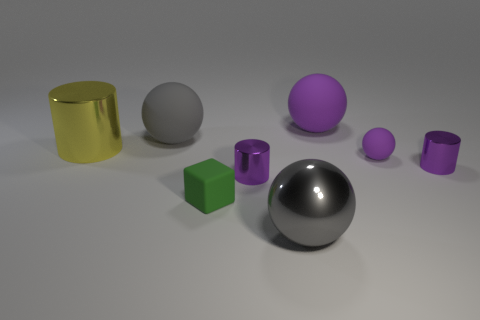Subtract 1 spheres. How many spheres are left? 3 Add 1 shiny cylinders. How many objects exist? 9 Subtract all cylinders. How many objects are left? 5 Subtract all spheres. Subtract all tiny purple metal objects. How many objects are left? 2 Add 1 big gray rubber things. How many big gray rubber things are left? 2 Add 1 shiny cylinders. How many shiny cylinders exist? 4 Subtract 0 gray blocks. How many objects are left? 8 